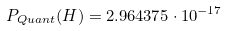Convert formula to latex. <formula><loc_0><loc_0><loc_500><loc_500>P _ { Q u a n t } ( H ) = 2 . 9 6 4 3 7 5 \cdot 1 0 ^ { - 1 7 }</formula> 